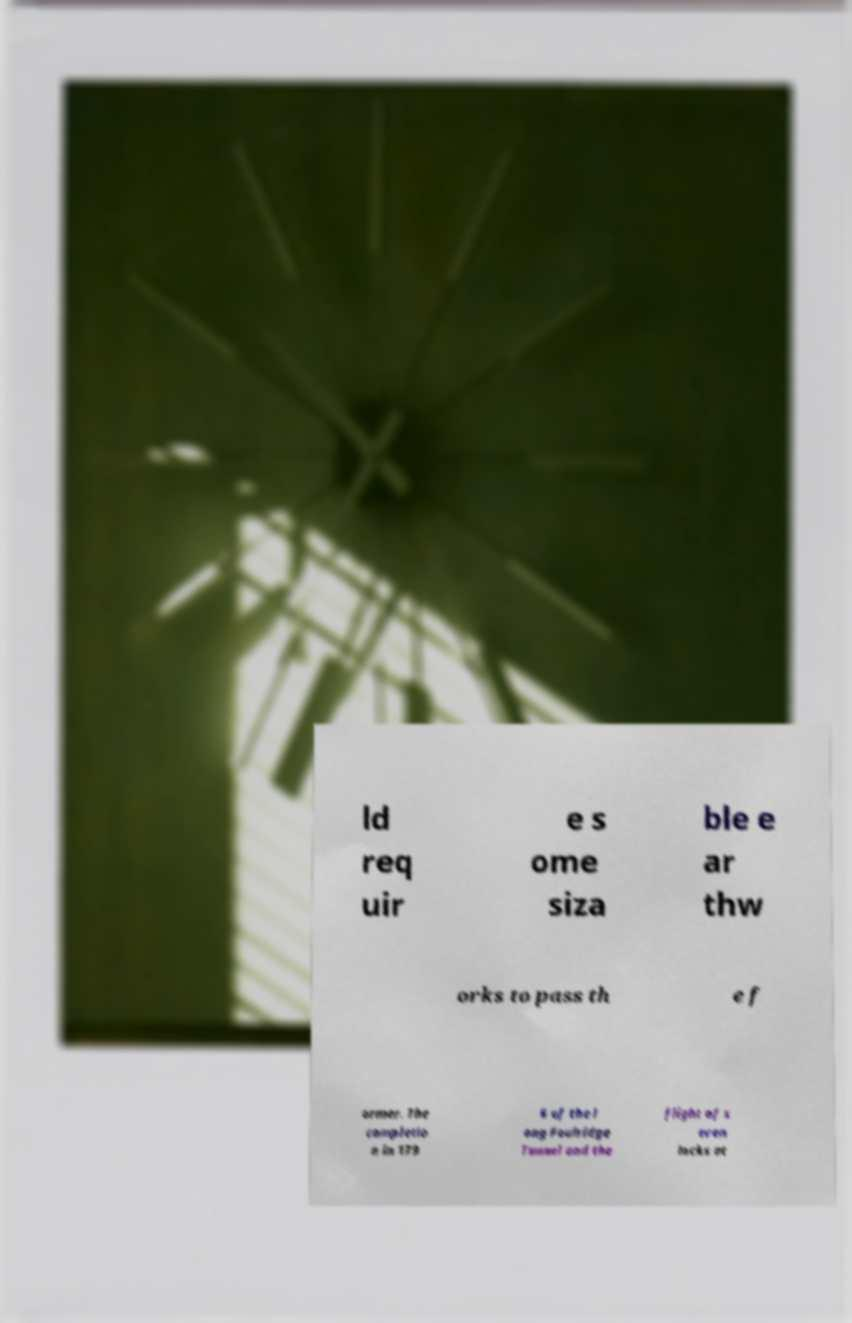Could you extract and type out the text from this image? ld req uir e s ome siza ble e ar thw orks to pass th e f ormer. The completio n in 179 6 of the l ong Foulridge Tunnel and the flight of s even locks at 